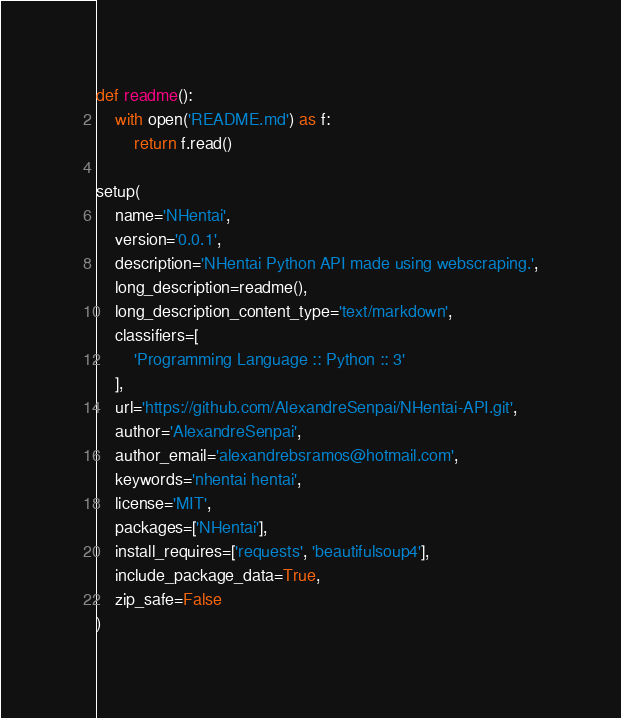Convert code to text. <code><loc_0><loc_0><loc_500><loc_500><_Python_>
def readme():
    with open('README.md') as f:
        return f.read()

setup(
    name='NHentai',
    version='0.0.1',
    description='NHentai Python API made using webscraping.',
    long_description=readme(),
    long_description_content_type='text/markdown',
    classifiers=[
        'Programming Language :: Python :: 3'
    ],
    url='https://github.com/AlexandreSenpai/NHentai-API.git',
    author='AlexandreSenpai',
    author_email='alexandrebsramos@hotmail.com',
    keywords='nhentai hentai',
    license='MIT',
    packages=['NHentai'],
    install_requires=['requests', 'beautifulsoup4'],
    include_package_data=True,
    zip_safe=False
)</code> 